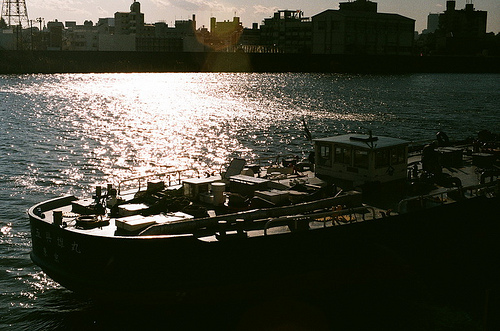What color are the clouds in the sky? The clouds captured in the photograph are predominantly white, softly illuminated by the sunlight. 